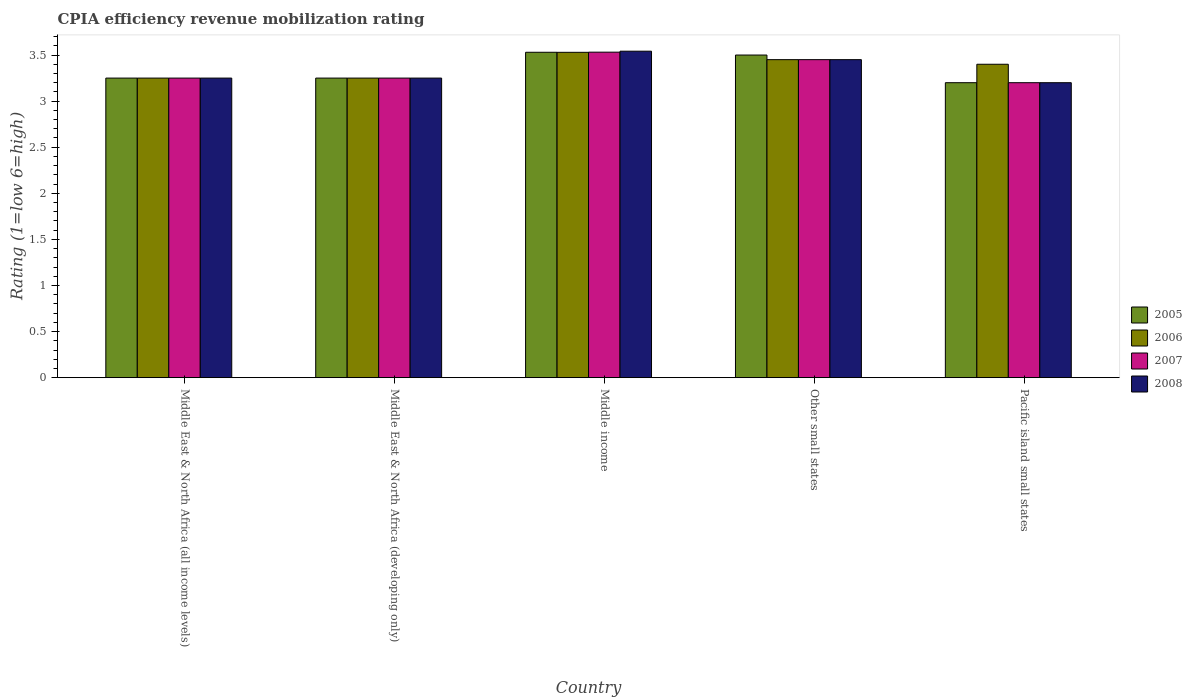Are the number of bars per tick equal to the number of legend labels?
Your answer should be very brief. Yes. Are the number of bars on each tick of the X-axis equal?
Your answer should be compact. Yes. How many bars are there on the 1st tick from the left?
Your answer should be compact. 4. What is the label of the 3rd group of bars from the left?
Offer a terse response. Middle income. In how many cases, is the number of bars for a given country not equal to the number of legend labels?
Your answer should be very brief. 0. What is the CPIA rating in 2005 in Middle income?
Your answer should be compact. 3.53. Across all countries, what is the maximum CPIA rating in 2008?
Offer a terse response. 3.54. In which country was the CPIA rating in 2006 minimum?
Your answer should be compact. Middle East & North Africa (all income levels). What is the total CPIA rating in 2006 in the graph?
Make the answer very short. 16.88. What is the difference between the CPIA rating in 2006 in Middle income and that in Other small states?
Your response must be concise. 0.08. What is the difference between the CPIA rating in 2008 in Pacific island small states and the CPIA rating in 2005 in Middle income?
Ensure brevity in your answer.  -0.33. What is the average CPIA rating in 2006 per country?
Keep it short and to the point. 3.38. What is the difference between the CPIA rating of/in 2007 and CPIA rating of/in 2008 in Middle East & North Africa (all income levels)?
Offer a terse response. 0. In how many countries, is the CPIA rating in 2008 greater than 2.9?
Give a very brief answer. 5. What is the ratio of the CPIA rating in 2008 in Middle income to that in Pacific island small states?
Offer a very short reply. 1.11. Is the CPIA rating in 2005 in Middle East & North Africa (developing only) less than that in Middle income?
Your answer should be compact. Yes. What is the difference between the highest and the second highest CPIA rating in 2008?
Provide a short and direct response. 0.2. What is the difference between the highest and the lowest CPIA rating in 2008?
Your response must be concise. 0.34. Is the sum of the CPIA rating in 2005 in Middle East & North Africa (developing only) and Other small states greater than the maximum CPIA rating in 2006 across all countries?
Make the answer very short. Yes. Is it the case that in every country, the sum of the CPIA rating in 2005 and CPIA rating in 2006 is greater than the sum of CPIA rating in 2007 and CPIA rating in 2008?
Offer a very short reply. No. What does the 3rd bar from the right in Middle East & North Africa (developing only) represents?
Offer a terse response. 2006. Does the graph contain any zero values?
Provide a short and direct response. No. Does the graph contain grids?
Your response must be concise. No. Where does the legend appear in the graph?
Keep it short and to the point. Center right. How are the legend labels stacked?
Offer a very short reply. Vertical. What is the title of the graph?
Provide a short and direct response. CPIA efficiency revenue mobilization rating. What is the label or title of the X-axis?
Offer a terse response. Country. What is the Rating (1=low 6=high) in 2005 in Middle East & North Africa (all income levels)?
Keep it short and to the point. 3.25. What is the Rating (1=low 6=high) in 2006 in Middle East & North Africa (all income levels)?
Your response must be concise. 3.25. What is the Rating (1=low 6=high) of 2008 in Middle East & North Africa (all income levels)?
Provide a succinct answer. 3.25. What is the Rating (1=low 6=high) of 2006 in Middle East & North Africa (developing only)?
Your response must be concise. 3.25. What is the Rating (1=low 6=high) of 2005 in Middle income?
Your answer should be compact. 3.53. What is the Rating (1=low 6=high) in 2006 in Middle income?
Offer a terse response. 3.53. What is the Rating (1=low 6=high) of 2007 in Middle income?
Keep it short and to the point. 3.53. What is the Rating (1=low 6=high) in 2008 in Middle income?
Offer a terse response. 3.54. What is the Rating (1=low 6=high) of 2005 in Other small states?
Offer a very short reply. 3.5. What is the Rating (1=low 6=high) in 2006 in Other small states?
Provide a short and direct response. 3.45. What is the Rating (1=low 6=high) in 2007 in Other small states?
Offer a terse response. 3.45. What is the Rating (1=low 6=high) in 2008 in Other small states?
Give a very brief answer. 3.45. What is the Rating (1=low 6=high) in 2005 in Pacific island small states?
Give a very brief answer. 3.2. Across all countries, what is the maximum Rating (1=low 6=high) of 2005?
Ensure brevity in your answer.  3.53. Across all countries, what is the maximum Rating (1=low 6=high) in 2006?
Provide a succinct answer. 3.53. Across all countries, what is the maximum Rating (1=low 6=high) in 2007?
Offer a terse response. 3.53. Across all countries, what is the maximum Rating (1=low 6=high) in 2008?
Provide a succinct answer. 3.54. Across all countries, what is the minimum Rating (1=low 6=high) in 2006?
Make the answer very short. 3.25. Across all countries, what is the minimum Rating (1=low 6=high) of 2007?
Offer a very short reply. 3.2. What is the total Rating (1=low 6=high) in 2005 in the graph?
Ensure brevity in your answer.  16.73. What is the total Rating (1=low 6=high) in 2006 in the graph?
Provide a succinct answer. 16.88. What is the total Rating (1=low 6=high) of 2007 in the graph?
Keep it short and to the point. 16.68. What is the total Rating (1=low 6=high) of 2008 in the graph?
Offer a very short reply. 16.69. What is the difference between the Rating (1=low 6=high) of 2006 in Middle East & North Africa (all income levels) and that in Middle East & North Africa (developing only)?
Keep it short and to the point. 0. What is the difference between the Rating (1=low 6=high) in 2007 in Middle East & North Africa (all income levels) and that in Middle East & North Africa (developing only)?
Offer a very short reply. 0. What is the difference between the Rating (1=low 6=high) in 2005 in Middle East & North Africa (all income levels) and that in Middle income?
Give a very brief answer. -0.28. What is the difference between the Rating (1=low 6=high) of 2006 in Middle East & North Africa (all income levels) and that in Middle income?
Offer a very short reply. -0.28. What is the difference between the Rating (1=low 6=high) in 2007 in Middle East & North Africa (all income levels) and that in Middle income?
Provide a succinct answer. -0.28. What is the difference between the Rating (1=low 6=high) of 2008 in Middle East & North Africa (all income levels) and that in Middle income?
Offer a very short reply. -0.29. What is the difference between the Rating (1=low 6=high) in 2005 in Middle East & North Africa (all income levels) and that in Other small states?
Make the answer very short. -0.25. What is the difference between the Rating (1=low 6=high) in 2006 in Middle East & North Africa (all income levels) and that in Other small states?
Ensure brevity in your answer.  -0.2. What is the difference between the Rating (1=low 6=high) in 2007 in Middle East & North Africa (all income levels) and that in Other small states?
Your answer should be compact. -0.2. What is the difference between the Rating (1=low 6=high) of 2005 in Middle East & North Africa (all income levels) and that in Pacific island small states?
Provide a succinct answer. 0.05. What is the difference between the Rating (1=low 6=high) in 2006 in Middle East & North Africa (all income levels) and that in Pacific island small states?
Your answer should be compact. -0.15. What is the difference between the Rating (1=low 6=high) in 2007 in Middle East & North Africa (all income levels) and that in Pacific island small states?
Your answer should be very brief. 0.05. What is the difference between the Rating (1=low 6=high) of 2005 in Middle East & North Africa (developing only) and that in Middle income?
Keep it short and to the point. -0.28. What is the difference between the Rating (1=low 6=high) in 2006 in Middle East & North Africa (developing only) and that in Middle income?
Provide a short and direct response. -0.28. What is the difference between the Rating (1=low 6=high) in 2007 in Middle East & North Africa (developing only) and that in Middle income?
Ensure brevity in your answer.  -0.28. What is the difference between the Rating (1=low 6=high) in 2008 in Middle East & North Africa (developing only) and that in Middle income?
Keep it short and to the point. -0.29. What is the difference between the Rating (1=low 6=high) in 2005 in Middle East & North Africa (developing only) and that in Other small states?
Your answer should be very brief. -0.25. What is the difference between the Rating (1=low 6=high) of 2006 in Middle East & North Africa (developing only) and that in Other small states?
Make the answer very short. -0.2. What is the difference between the Rating (1=low 6=high) in 2007 in Middle East & North Africa (developing only) and that in Other small states?
Provide a succinct answer. -0.2. What is the difference between the Rating (1=low 6=high) in 2008 in Middle East & North Africa (developing only) and that in Other small states?
Offer a very short reply. -0.2. What is the difference between the Rating (1=low 6=high) of 2006 in Middle East & North Africa (developing only) and that in Pacific island small states?
Offer a very short reply. -0.15. What is the difference between the Rating (1=low 6=high) in 2005 in Middle income and that in Other small states?
Provide a succinct answer. 0.03. What is the difference between the Rating (1=low 6=high) of 2006 in Middle income and that in Other small states?
Keep it short and to the point. 0.08. What is the difference between the Rating (1=low 6=high) of 2007 in Middle income and that in Other small states?
Your answer should be compact. 0.08. What is the difference between the Rating (1=low 6=high) of 2008 in Middle income and that in Other small states?
Offer a terse response. 0.09. What is the difference between the Rating (1=low 6=high) in 2005 in Middle income and that in Pacific island small states?
Keep it short and to the point. 0.33. What is the difference between the Rating (1=low 6=high) in 2006 in Middle income and that in Pacific island small states?
Ensure brevity in your answer.  0.13. What is the difference between the Rating (1=low 6=high) of 2007 in Middle income and that in Pacific island small states?
Keep it short and to the point. 0.33. What is the difference between the Rating (1=low 6=high) in 2008 in Middle income and that in Pacific island small states?
Provide a short and direct response. 0.34. What is the difference between the Rating (1=low 6=high) of 2005 in Other small states and that in Pacific island small states?
Provide a succinct answer. 0.3. What is the difference between the Rating (1=low 6=high) of 2007 in Other small states and that in Pacific island small states?
Keep it short and to the point. 0.25. What is the difference between the Rating (1=low 6=high) of 2008 in Other small states and that in Pacific island small states?
Provide a succinct answer. 0.25. What is the difference between the Rating (1=low 6=high) in 2006 in Middle East & North Africa (all income levels) and the Rating (1=low 6=high) in 2008 in Middle East & North Africa (developing only)?
Make the answer very short. 0. What is the difference between the Rating (1=low 6=high) of 2007 in Middle East & North Africa (all income levels) and the Rating (1=low 6=high) of 2008 in Middle East & North Africa (developing only)?
Your answer should be very brief. 0. What is the difference between the Rating (1=low 6=high) of 2005 in Middle East & North Africa (all income levels) and the Rating (1=low 6=high) of 2006 in Middle income?
Provide a short and direct response. -0.28. What is the difference between the Rating (1=low 6=high) in 2005 in Middle East & North Africa (all income levels) and the Rating (1=low 6=high) in 2007 in Middle income?
Provide a succinct answer. -0.28. What is the difference between the Rating (1=low 6=high) of 2005 in Middle East & North Africa (all income levels) and the Rating (1=low 6=high) of 2008 in Middle income?
Offer a very short reply. -0.29. What is the difference between the Rating (1=low 6=high) in 2006 in Middle East & North Africa (all income levels) and the Rating (1=low 6=high) in 2007 in Middle income?
Provide a short and direct response. -0.28. What is the difference between the Rating (1=low 6=high) in 2006 in Middle East & North Africa (all income levels) and the Rating (1=low 6=high) in 2008 in Middle income?
Offer a terse response. -0.29. What is the difference between the Rating (1=low 6=high) of 2007 in Middle East & North Africa (all income levels) and the Rating (1=low 6=high) of 2008 in Middle income?
Provide a short and direct response. -0.29. What is the difference between the Rating (1=low 6=high) of 2005 in Middle East & North Africa (all income levels) and the Rating (1=low 6=high) of 2006 in Other small states?
Your answer should be compact. -0.2. What is the difference between the Rating (1=low 6=high) of 2005 in Middle East & North Africa (all income levels) and the Rating (1=low 6=high) of 2007 in Other small states?
Your answer should be very brief. -0.2. What is the difference between the Rating (1=low 6=high) of 2006 in Middle East & North Africa (all income levels) and the Rating (1=low 6=high) of 2007 in Other small states?
Provide a succinct answer. -0.2. What is the difference between the Rating (1=low 6=high) in 2005 in Middle East & North Africa (all income levels) and the Rating (1=low 6=high) in 2006 in Pacific island small states?
Offer a very short reply. -0.15. What is the difference between the Rating (1=low 6=high) of 2005 in Middle East & North Africa (all income levels) and the Rating (1=low 6=high) of 2007 in Pacific island small states?
Ensure brevity in your answer.  0.05. What is the difference between the Rating (1=low 6=high) of 2006 in Middle East & North Africa (all income levels) and the Rating (1=low 6=high) of 2008 in Pacific island small states?
Keep it short and to the point. 0.05. What is the difference between the Rating (1=low 6=high) of 2005 in Middle East & North Africa (developing only) and the Rating (1=low 6=high) of 2006 in Middle income?
Offer a very short reply. -0.28. What is the difference between the Rating (1=low 6=high) of 2005 in Middle East & North Africa (developing only) and the Rating (1=low 6=high) of 2007 in Middle income?
Make the answer very short. -0.28. What is the difference between the Rating (1=low 6=high) in 2005 in Middle East & North Africa (developing only) and the Rating (1=low 6=high) in 2008 in Middle income?
Provide a succinct answer. -0.29. What is the difference between the Rating (1=low 6=high) in 2006 in Middle East & North Africa (developing only) and the Rating (1=low 6=high) in 2007 in Middle income?
Offer a very short reply. -0.28. What is the difference between the Rating (1=low 6=high) of 2006 in Middle East & North Africa (developing only) and the Rating (1=low 6=high) of 2008 in Middle income?
Give a very brief answer. -0.29. What is the difference between the Rating (1=low 6=high) of 2007 in Middle East & North Africa (developing only) and the Rating (1=low 6=high) of 2008 in Middle income?
Your answer should be compact. -0.29. What is the difference between the Rating (1=low 6=high) in 2005 in Middle East & North Africa (developing only) and the Rating (1=low 6=high) in 2006 in Other small states?
Keep it short and to the point. -0.2. What is the difference between the Rating (1=low 6=high) of 2005 in Middle East & North Africa (developing only) and the Rating (1=low 6=high) of 2008 in Other small states?
Offer a very short reply. -0.2. What is the difference between the Rating (1=low 6=high) of 2006 in Middle East & North Africa (developing only) and the Rating (1=low 6=high) of 2007 in Other small states?
Your answer should be very brief. -0.2. What is the difference between the Rating (1=low 6=high) in 2006 in Middle East & North Africa (developing only) and the Rating (1=low 6=high) in 2008 in Other small states?
Your response must be concise. -0.2. What is the difference between the Rating (1=low 6=high) of 2005 in Middle East & North Africa (developing only) and the Rating (1=low 6=high) of 2006 in Pacific island small states?
Provide a succinct answer. -0.15. What is the difference between the Rating (1=low 6=high) of 2005 in Middle East & North Africa (developing only) and the Rating (1=low 6=high) of 2007 in Pacific island small states?
Make the answer very short. 0.05. What is the difference between the Rating (1=low 6=high) in 2007 in Middle East & North Africa (developing only) and the Rating (1=low 6=high) in 2008 in Pacific island small states?
Provide a short and direct response. 0.05. What is the difference between the Rating (1=low 6=high) of 2005 in Middle income and the Rating (1=low 6=high) of 2006 in Other small states?
Your response must be concise. 0.08. What is the difference between the Rating (1=low 6=high) of 2006 in Middle income and the Rating (1=low 6=high) of 2007 in Other small states?
Ensure brevity in your answer.  0.08. What is the difference between the Rating (1=low 6=high) in 2006 in Middle income and the Rating (1=low 6=high) in 2008 in Other small states?
Give a very brief answer. 0.08. What is the difference between the Rating (1=low 6=high) in 2007 in Middle income and the Rating (1=low 6=high) in 2008 in Other small states?
Make the answer very short. 0.08. What is the difference between the Rating (1=low 6=high) of 2005 in Middle income and the Rating (1=low 6=high) of 2006 in Pacific island small states?
Your answer should be very brief. 0.13. What is the difference between the Rating (1=low 6=high) of 2005 in Middle income and the Rating (1=low 6=high) of 2007 in Pacific island small states?
Your response must be concise. 0.33. What is the difference between the Rating (1=low 6=high) of 2005 in Middle income and the Rating (1=low 6=high) of 2008 in Pacific island small states?
Provide a short and direct response. 0.33. What is the difference between the Rating (1=low 6=high) of 2006 in Middle income and the Rating (1=low 6=high) of 2007 in Pacific island small states?
Make the answer very short. 0.33. What is the difference between the Rating (1=low 6=high) in 2006 in Middle income and the Rating (1=low 6=high) in 2008 in Pacific island small states?
Keep it short and to the point. 0.33. What is the difference between the Rating (1=low 6=high) in 2007 in Middle income and the Rating (1=low 6=high) in 2008 in Pacific island small states?
Your answer should be compact. 0.33. What is the difference between the Rating (1=low 6=high) of 2005 in Other small states and the Rating (1=low 6=high) of 2007 in Pacific island small states?
Your answer should be compact. 0.3. What is the difference between the Rating (1=low 6=high) of 2006 in Other small states and the Rating (1=low 6=high) of 2008 in Pacific island small states?
Offer a terse response. 0.25. What is the difference between the Rating (1=low 6=high) in 2007 in Other small states and the Rating (1=low 6=high) in 2008 in Pacific island small states?
Your answer should be compact. 0.25. What is the average Rating (1=low 6=high) of 2005 per country?
Make the answer very short. 3.35. What is the average Rating (1=low 6=high) in 2006 per country?
Give a very brief answer. 3.38. What is the average Rating (1=low 6=high) of 2007 per country?
Your answer should be compact. 3.34. What is the average Rating (1=low 6=high) of 2008 per country?
Your answer should be very brief. 3.34. What is the difference between the Rating (1=low 6=high) of 2005 and Rating (1=low 6=high) of 2006 in Middle East & North Africa (all income levels)?
Keep it short and to the point. 0. What is the difference between the Rating (1=low 6=high) of 2005 and Rating (1=low 6=high) of 2007 in Middle East & North Africa (all income levels)?
Ensure brevity in your answer.  0. What is the difference between the Rating (1=low 6=high) of 2007 and Rating (1=low 6=high) of 2008 in Middle East & North Africa (all income levels)?
Give a very brief answer. 0. What is the difference between the Rating (1=low 6=high) in 2005 and Rating (1=low 6=high) in 2006 in Middle East & North Africa (developing only)?
Your answer should be compact. 0. What is the difference between the Rating (1=low 6=high) of 2005 and Rating (1=low 6=high) of 2007 in Middle East & North Africa (developing only)?
Provide a succinct answer. 0. What is the difference between the Rating (1=low 6=high) in 2005 and Rating (1=low 6=high) in 2008 in Middle East & North Africa (developing only)?
Ensure brevity in your answer.  0. What is the difference between the Rating (1=low 6=high) of 2006 and Rating (1=low 6=high) of 2007 in Middle East & North Africa (developing only)?
Ensure brevity in your answer.  0. What is the difference between the Rating (1=low 6=high) in 2006 and Rating (1=low 6=high) in 2008 in Middle East & North Africa (developing only)?
Make the answer very short. 0. What is the difference between the Rating (1=low 6=high) in 2007 and Rating (1=low 6=high) in 2008 in Middle East & North Africa (developing only)?
Your answer should be compact. 0. What is the difference between the Rating (1=low 6=high) of 2005 and Rating (1=low 6=high) of 2006 in Middle income?
Keep it short and to the point. 0. What is the difference between the Rating (1=low 6=high) in 2005 and Rating (1=low 6=high) in 2007 in Middle income?
Offer a terse response. -0. What is the difference between the Rating (1=low 6=high) of 2005 and Rating (1=low 6=high) of 2008 in Middle income?
Your answer should be very brief. -0.01. What is the difference between the Rating (1=low 6=high) in 2006 and Rating (1=low 6=high) in 2007 in Middle income?
Keep it short and to the point. -0. What is the difference between the Rating (1=low 6=high) in 2006 and Rating (1=low 6=high) in 2008 in Middle income?
Provide a succinct answer. -0.01. What is the difference between the Rating (1=low 6=high) of 2007 and Rating (1=low 6=high) of 2008 in Middle income?
Make the answer very short. -0.01. What is the difference between the Rating (1=low 6=high) of 2005 and Rating (1=low 6=high) of 2006 in Other small states?
Make the answer very short. 0.05. What is the difference between the Rating (1=low 6=high) in 2005 and Rating (1=low 6=high) in 2007 in Other small states?
Give a very brief answer. 0.05. What is the difference between the Rating (1=low 6=high) in 2006 and Rating (1=low 6=high) in 2008 in Other small states?
Make the answer very short. 0. What is the difference between the Rating (1=low 6=high) of 2007 and Rating (1=low 6=high) of 2008 in Other small states?
Offer a terse response. 0. What is the difference between the Rating (1=low 6=high) of 2005 and Rating (1=low 6=high) of 2006 in Pacific island small states?
Keep it short and to the point. -0.2. What is the difference between the Rating (1=low 6=high) in 2005 and Rating (1=low 6=high) in 2007 in Pacific island small states?
Provide a short and direct response. 0. What is the difference between the Rating (1=low 6=high) of 2006 and Rating (1=low 6=high) of 2007 in Pacific island small states?
Keep it short and to the point. 0.2. What is the ratio of the Rating (1=low 6=high) of 2005 in Middle East & North Africa (all income levels) to that in Middle income?
Give a very brief answer. 0.92. What is the ratio of the Rating (1=low 6=high) of 2006 in Middle East & North Africa (all income levels) to that in Middle income?
Make the answer very short. 0.92. What is the ratio of the Rating (1=low 6=high) of 2007 in Middle East & North Africa (all income levels) to that in Middle income?
Make the answer very short. 0.92. What is the ratio of the Rating (1=low 6=high) of 2008 in Middle East & North Africa (all income levels) to that in Middle income?
Ensure brevity in your answer.  0.92. What is the ratio of the Rating (1=low 6=high) in 2005 in Middle East & North Africa (all income levels) to that in Other small states?
Provide a succinct answer. 0.93. What is the ratio of the Rating (1=low 6=high) of 2006 in Middle East & North Africa (all income levels) to that in Other small states?
Your response must be concise. 0.94. What is the ratio of the Rating (1=low 6=high) in 2007 in Middle East & North Africa (all income levels) to that in Other small states?
Your answer should be very brief. 0.94. What is the ratio of the Rating (1=low 6=high) of 2008 in Middle East & North Africa (all income levels) to that in Other small states?
Keep it short and to the point. 0.94. What is the ratio of the Rating (1=low 6=high) of 2005 in Middle East & North Africa (all income levels) to that in Pacific island small states?
Your response must be concise. 1.02. What is the ratio of the Rating (1=low 6=high) of 2006 in Middle East & North Africa (all income levels) to that in Pacific island small states?
Provide a short and direct response. 0.96. What is the ratio of the Rating (1=low 6=high) in 2007 in Middle East & North Africa (all income levels) to that in Pacific island small states?
Give a very brief answer. 1.02. What is the ratio of the Rating (1=low 6=high) in 2008 in Middle East & North Africa (all income levels) to that in Pacific island small states?
Offer a terse response. 1.02. What is the ratio of the Rating (1=low 6=high) of 2005 in Middle East & North Africa (developing only) to that in Middle income?
Offer a very short reply. 0.92. What is the ratio of the Rating (1=low 6=high) in 2006 in Middle East & North Africa (developing only) to that in Middle income?
Provide a succinct answer. 0.92. What is the ratio of the Rating (1=low 6=high) of 2007 in Middle East & North Africa (developing only) to that in Middle income?
Offer a terse response. 0.92. What is the ratio of the Rating (1=low 6=high) of 2008 in Middle East & North Africa (developing only) to that in Middle income?
Your response must be concise. 0.92. What is the ratio of the Rating (1=low 6=high) of 2006 in Middle East & North Africa (developing only) to that in Other small states?
Provide a short and direct response. 0.94. What is the ratio of the Rating (1=low 6=high) in 2007 in Middle East & North Africa (developing only) to that in Other small states?
Offer a very short reply. 0.94. What is the ratio of the Rating (1=low 6=high) in 2008 in Middle East & North Africa (developing only) to that in Other small states?
Your answer should be very brief. 0.94. What is the ratio of the Rating (1=low 6=high) in 2005 in Middle East & North Africa (developing only) to that in Pacific island small states?
Your response must be concise. 1.02. What is the ratio of the Rating (1=low 6=high) of 2006 in Middle East & North Africa (developing only) to that in Pacific island small states?
Provide a succinct answer. 0.96. What is the ratio of the Rating (1=low 6=high) of 2007 in Middle East & North Africa (developing only) to that in Pacific island small states?
Offer a very short reply. 1.02. What is the ratio of the Rating (1=low 6=high) of 2008 in Middle East & North Africa (developing only) to that in Pacific island small states?
Offer a very short reply. 1.02. What is the ratio of the Rating (1=low 6=high) in 2005 in Middle income to that in Other small states?
Offer a very short reply. 1.01. What is the ratio of the Rating (1=low 6=high) in 2006 in Middle income to that in Other small states?
Your response must be concise. 1.02. What is the ratio of the Rating (1=low 6=high) in 2007 in Middle income to that in Other small states?
Provide a short and direct response. 1.02. What is the ratio of the Rating (1=low 6=high) of 2008 in Middle income to that in Other small states?
Give a very brief answer. 1.03. What is the ratio of the Rating (1=low 6=high) in 2005 in Middle income to that in Pacific island small states?
Provide a short and direct response. 1.1. What is the ratio of the Rating (1=low 6=high) in 2006 in Middle income to that in Pacific island small states?
Keep it short and to the point. 1.04. What is the ratio of the Rating (1=low 6=high) of 2007 in Middle income to that in Pacific island small states?
Your answer should be very brief. 1.1. What is the ratio of the Rating (1=low 6=high) in 2008 in Middle income to that in Pacific island small states?
Make the answer very short. 1.11. What is the ratio of the Rating (1=low 6=high) of 2005 in Other small states to that in Pacific island small states?
Offer a very short reply. 1.09. What is the ratio of the Rating (1=low 6=high) in 2006 in Other small states to that in Pacific island small states?
Offer a very short reply. 1.01. What is the ratio of the Rating (1=low 6=high) of 2007 in Other small states to that in Pacific island small states?
Offer a very short reply. 1.08. What is the ratio of the Rating (1=low 6=high) of 2008 in Other small states to that in Pacific island small states?
Your answer should be very brief. 1.08. What is the difference between the highest and the second highest Rating (1=low 6=high) of 2005?
Offer a very short reply. 0.03. What is the difference between the highest and the second highest Rating (1=low 6=high) in 2006?
Your answer should be compact. 0.08. What is the difference between the highest and the second highest Rating (1=low 6=high) in 2007?
Ensure brevity in your answer.  0.08. What is the difference between the highest and the second highest Rating (1=low 6=high) of 2008?
Ensure brevity in your answer.  0.09. What is the difference between the highest and the lowest Rating (1=low 6=high) of 2005?
Provide a succinct answer. 0.33. What is the difference between the highest and the lowest Rating (1=low 6=high) of 2006?
Offer a very short reply. 0.28. What is the difference between the highest and the lowest Rating (1=low 6=high) in 2007?
Offer a terse response. 0.33. What is the difference between the highest and the lowest Rating (1=low 6=high) of 2008?
Provide a short and direct response. 0.34. 